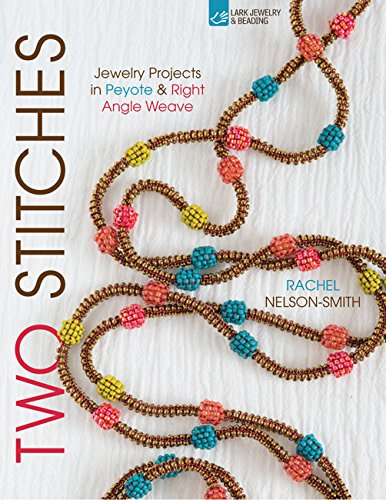Who wrote this book? The book 'Two Stitches: Jewelry Projects in Peyote & Right Angle Weave' is authored by Rachel Nelson-Smith, a recognized expert in beadwork. 